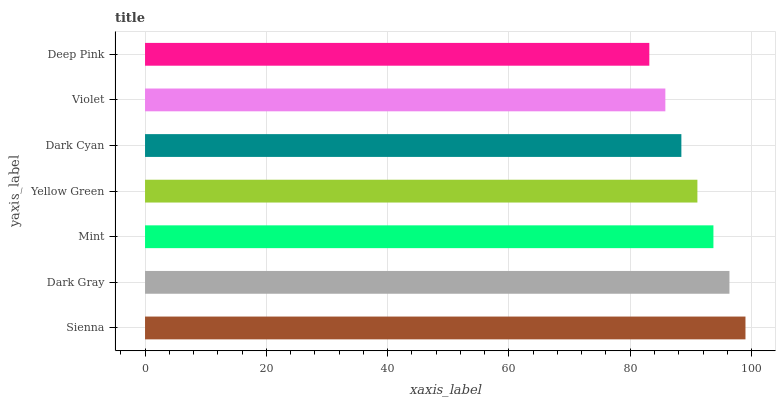Is Deep Pink the minimum?
Answer yes or no. Yes. Is Sienna the maximum?
Answer yes or no. Yes. Is Dark Gray the minimum?
Answer yes or no. No. Is Dark Gray the maximum?
Answer yes or no. No. Is Sienna greater than Dark Gray?
Answer yes or no. Yes. Is Dark Gray less than Sienna?
Answer yes or no. Yes. Is Dark Gray greater than Sienna?
Answer yes or no. No. Is Sienna less than Dark Gray?
Answer yes or no. No. Is Yellow Green the high median?
Answer yes or no. Yes. Is Yellow Green the low median?
Answer yes or no. Yes. Is Violet the high median?
Answer yes or no. No. Is Mint the low median?
Answer yes or no. No. 